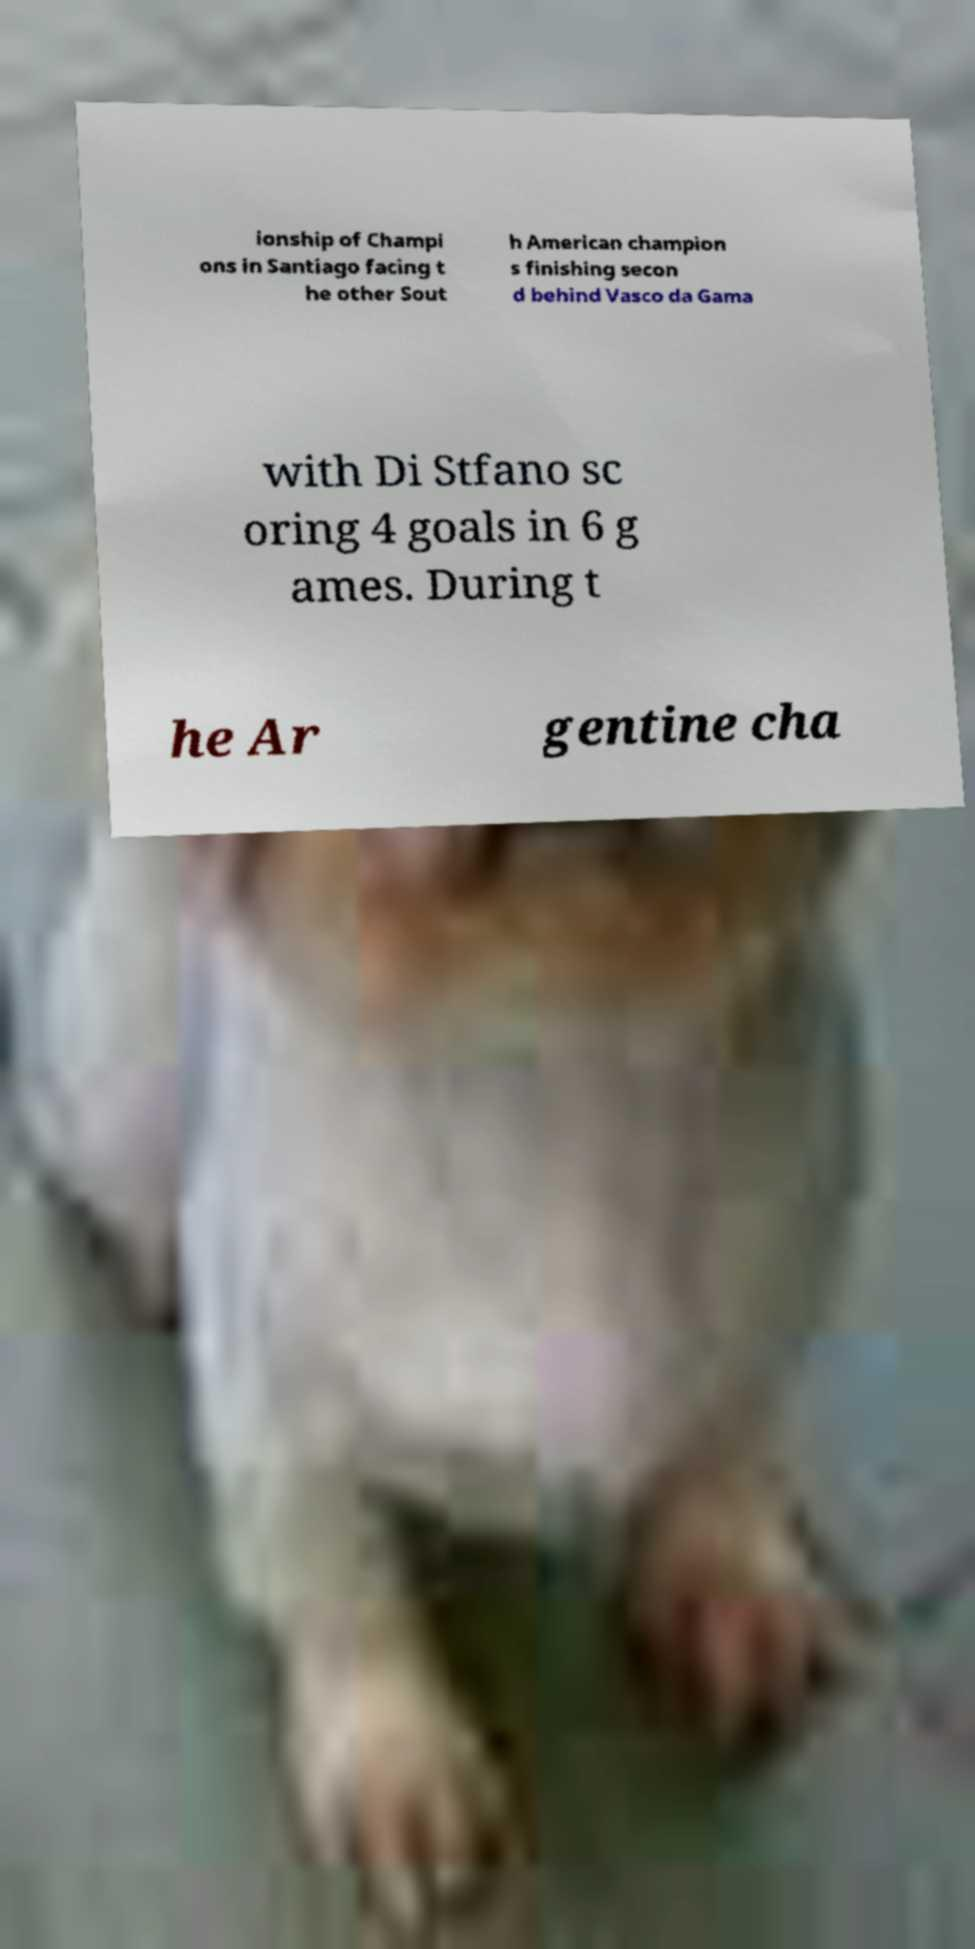Please read and relay the text visible in this image. What does it say? ionship of Champi ons in Santiago facing t he other Sout h American champion s finishing secon d behind Vasco da Gama with Di Stfano sc oring 4 goals in 6 g ames. During t he Ar gentine cha 